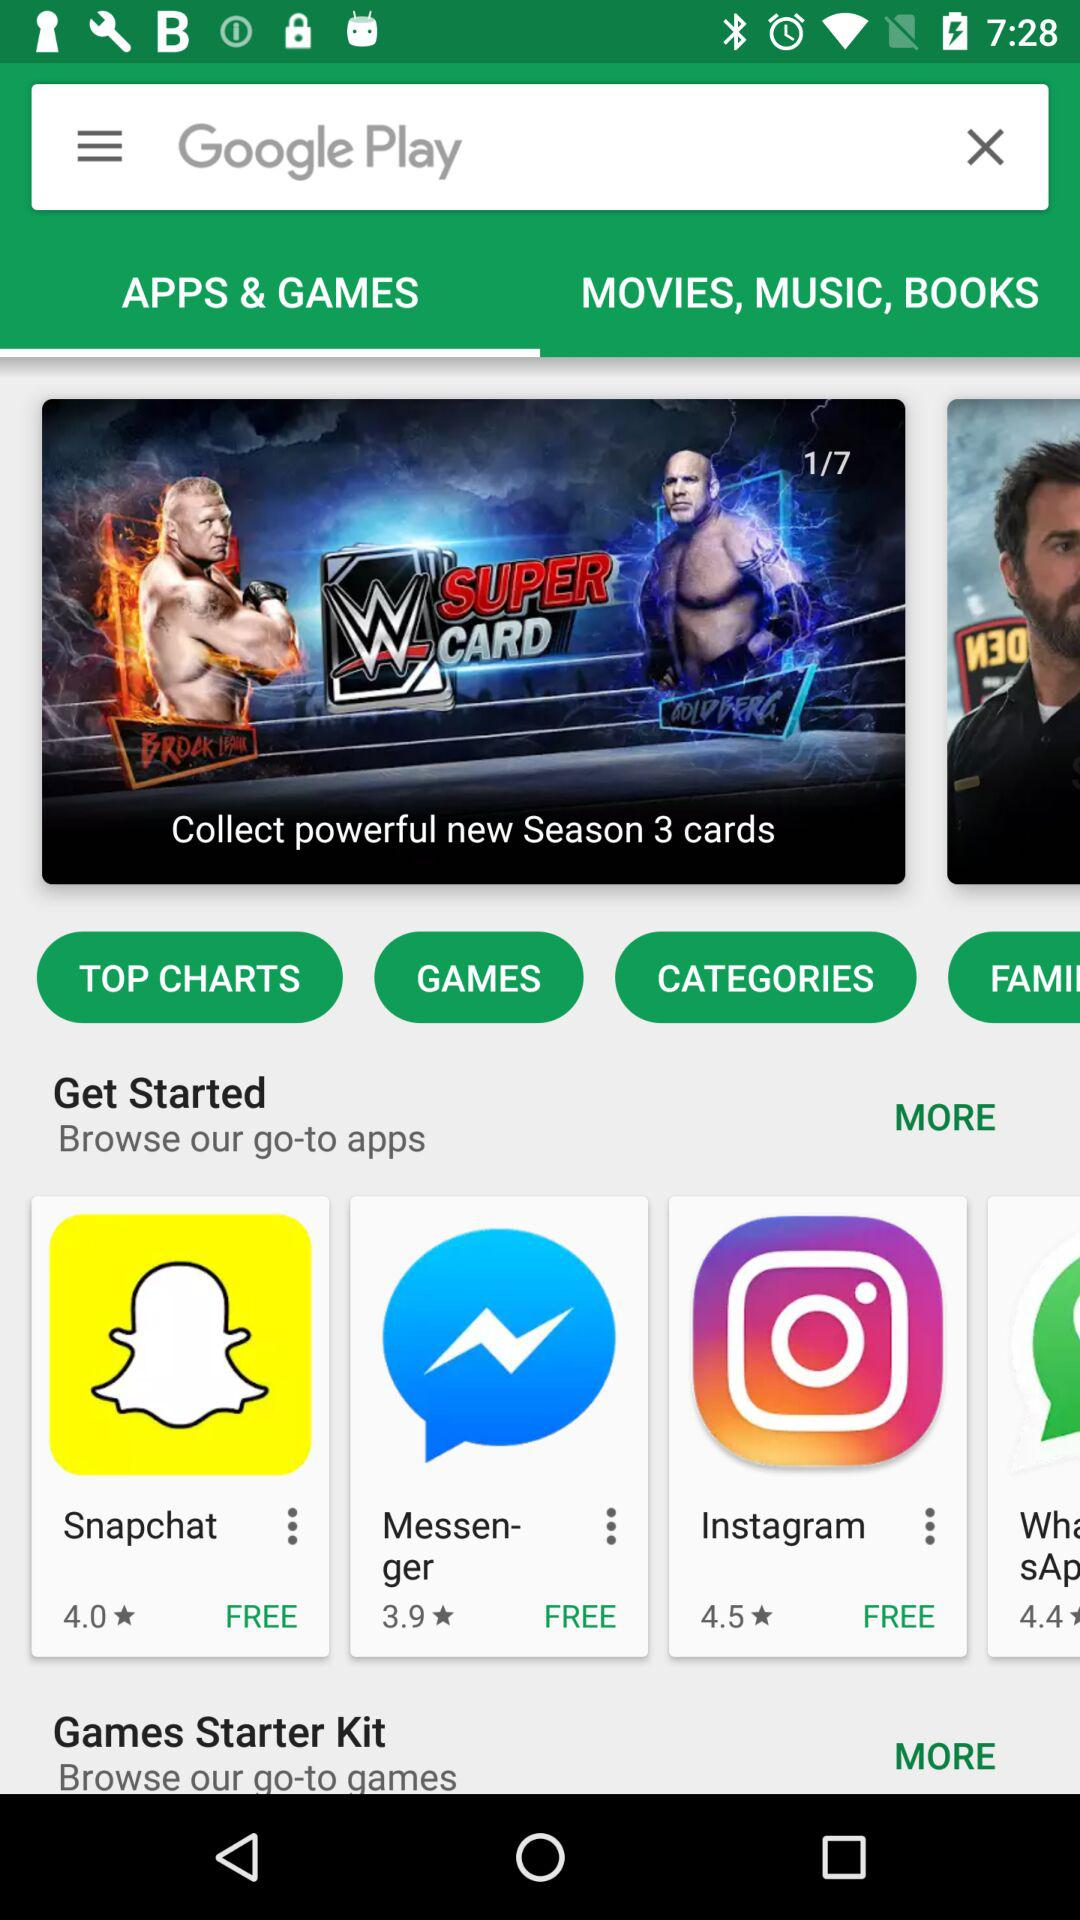How many more apps are in the "Games" category than the "Top Charts" category?
Answer the question using a single word or phrase. 2 